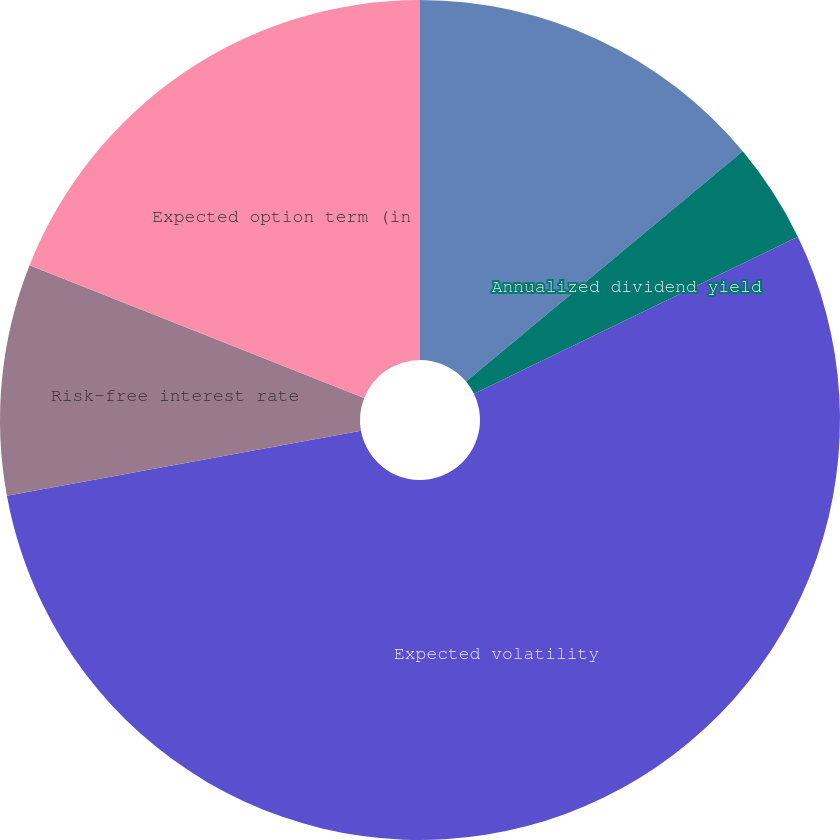<chart> <loc_0><loc_0><loc_500><loc_500><pie_chart><fcel>Fair value per option<fcel>Annualized dividend yield<fcel>Expected volatility<fcel>Risk-free interest rate<fcel>Expected option term (in<nl><fcel>13.95%<fcel>3.86%<fcel>54.3%<fcel>8.9%<fcel>18.99%<nl></chart> 